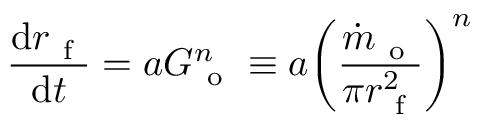Convert formula to latex. <formula><loc_0><loc_0><loc_500><loc_500>\frac { d r _ { f } } { d t } = a G _ { o } ^ { n } \equiv a \left ( \frac { \dot { m } _ { o } } { \pi r _ { f } ^ { 2 } } \right ) ^ { n }</formula> 